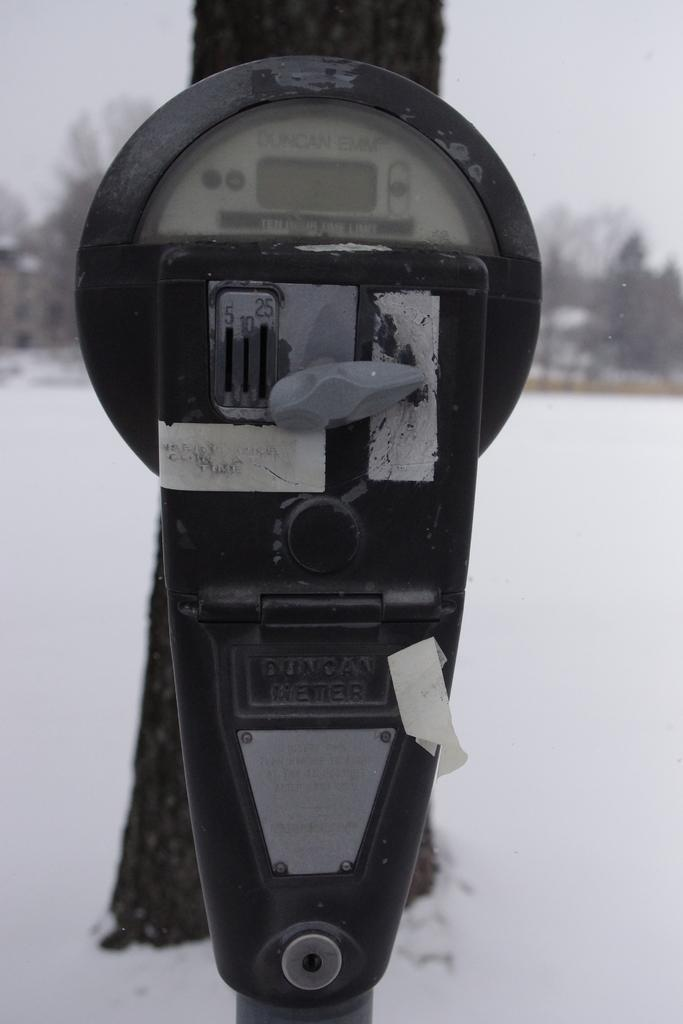<image>
Render a clear and concise summary of the photo. A black item in the snow, the word Duncan is discernible 